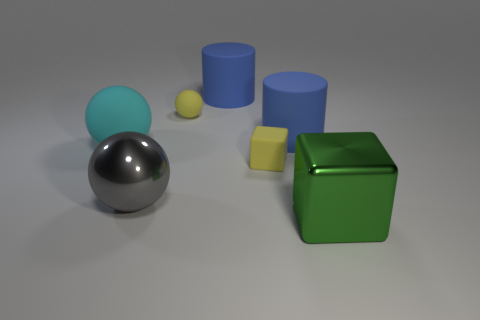There is a small sphere that is the same color as the tiny matte cube; what is its material?
Offer a terse response. Rubber. There is a yellow object that is the same shape as the big gray metal thing; what size is it?
Offer a very short reply. Small. Are there any large gray metal objects in front of the big cyan matte object?
Make the answer very short. Yes. There is a cube that is left of the large cube; is its color the same as the sphere that is to the right of the large metallic ball?
Offer a very short reply. Yes. Is there a tiny rubber object of the same shape as the large gray object?
Offer a terse response. Yes. What number of other things are the same color as the tiny sphere?
Ensure brevity in your answer.  1. The large metallic object that is on the left side of the blue matte cylinder that is on the left side of the large blue rubber object on the right side of the tiny matte block is what color?
Make the answer very short. Gray. Are there an equal number of large matte objects that are behind the matte block and small rubber blocks?
Provide a succinct answer. No. Does the cube on the left side of the shiny block have the same size as the big cyan rubber thing?
Give a very brief answer. No. What number of large blue matte objects are there?
Offer a terse response. 2. 